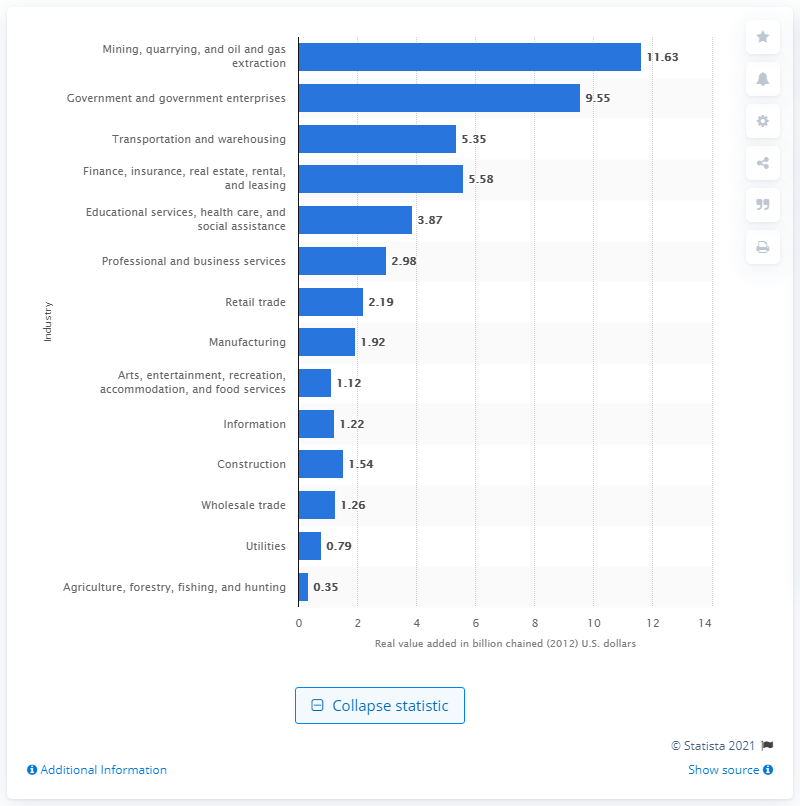Outline some significant characteristics in this image. In 2020, the mining, quarrying, and oil and gas extraction industry contributed 11.63 dollars to Alaska's Gross Domestic Product (GDP). 